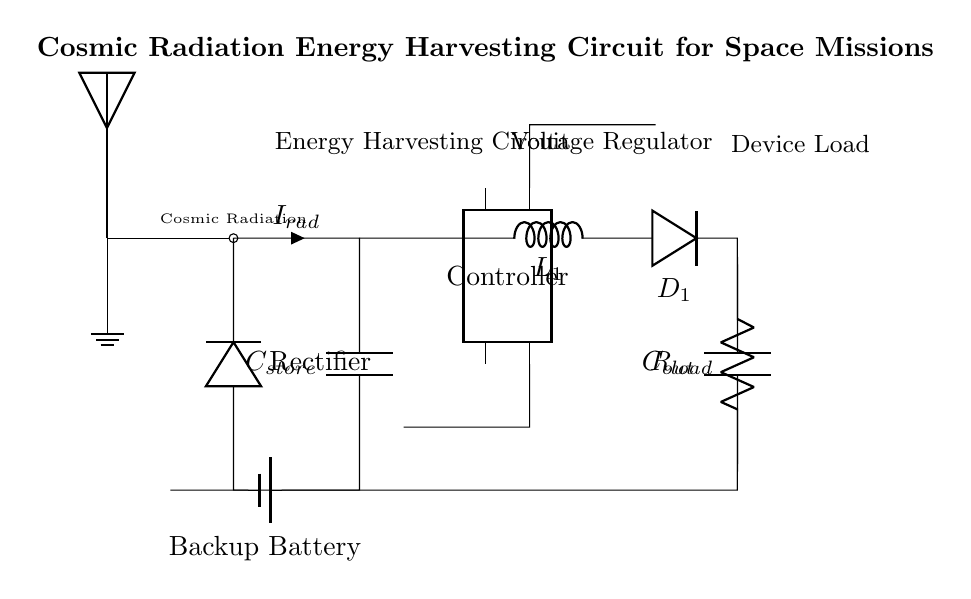What component detects cosmic radiation? The component that detects cosmic radiation is indicated as an antenna in the schematic. The label above it states "Cosmic Radiation".
Answer: Antenna What is the purpose of the capacitor labeled C_store? The capacitor labeled C_store serves to store energy harvested from cosmic radiation. It is the initial component that collects and holds the charge generated by the current from the radiation sensor.
Answer: Store energy How does the energy flow from the cosmic radiation sensor to the load? The energy flow starts from the antenna which collects cosmic radiation, leading to the storage capacitor C_store, through a rectifier which converts AC to DC, onwards to a voltage regulator, and finally to a load resistor R_load. This shows a complete path for energy utilization.
Answer: Through C_store, rectifier, voltage regulator What role does the controller play in the circuit? The controller provides control functions necessary for managing the distribution of harvested energy, likely regulating output voltage and current to the load, enhancing efficiency and stability.
Answer: Manage energy distribution What is the purpose of the backup battery in this circuit? The backup battery acts as an auxiliary power source, ensuring that the circuit has a power supply during times when cosmic radiation energy is insufficient, essentially providing reliability to the system.
Answer: Auxiliary power supply How many components are listed in the circuit diagram? The circuit diagram features a total of six components: an antenna (cosmic radiation sensor), a capacitor (C_store), a rectifier, an inductor (L_1), a voltage regulator, and a load resistor (R_load). Counting each unique component gives us this total.
Answer: Six components What kind of capacitor is indicated next to C_out? The capacitor next to C_out is labeled as C_out, which suggests that it is the output capacitor designed to smoothen the voltage output after regulation, providing stable output for the load.
Answer: Output capacitor 